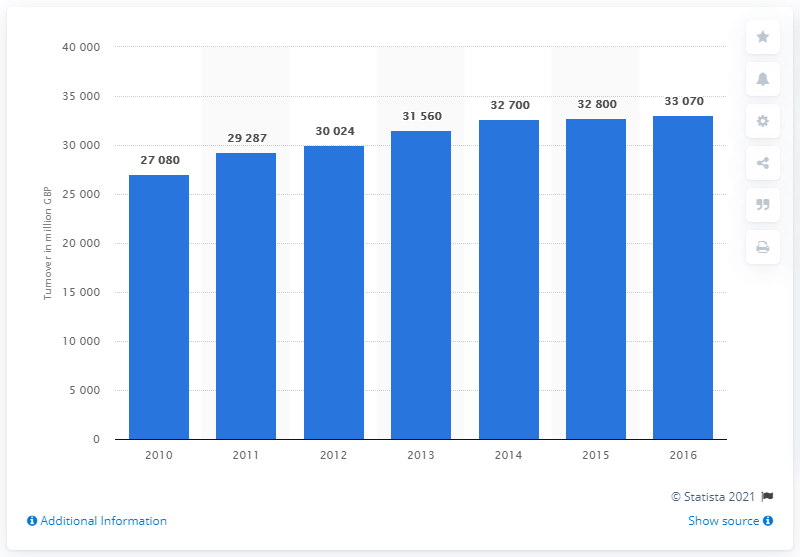Outline some significant characteristics in this image. In 2016, the total revenue generated by travel agents and tour operators was approximately 33,070. 